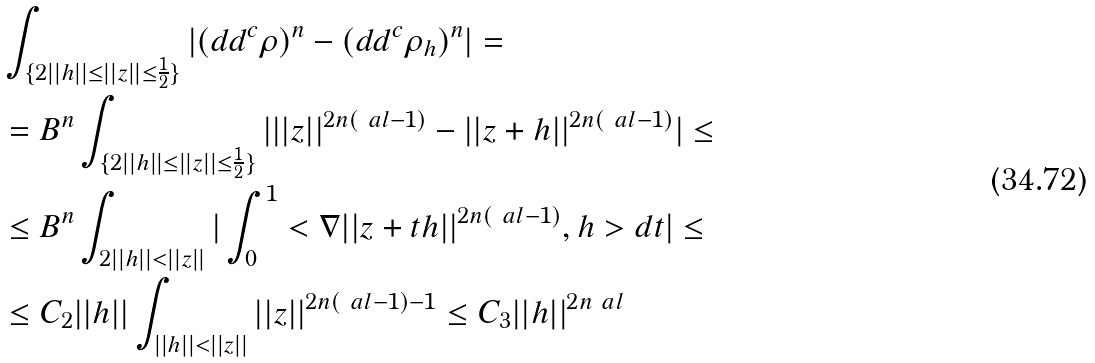<formula> <loc_0><loc_0><loc_500><loc_500>& \int _ { \{ 2 | | h | | \leq | | z | | \leq \frac { 1 } { 2 } \} } | ( d d ^ { c } \rho ) ^ { n } - ( d d ^ { c } \rho _ { h } ) ^ { n } | = \\ & = B ^ { n } \int _ { \{ 2 | | h | | \leq | | z | | \leq \frac { 1 } { 2 } \} } | | | z | | ^ { 2 n ( \ a l - 1 ) } - | | z + h | | ^ { 2 n ( \ a l - 1 ) } | \leq \\ & \leq B ^ { n } \int _ { 2 | | h | | < | | z | | } | \int _ { 0 } ^ { 1 } < \nabla | | z + t h | | ^ { 2 n ( \ a l - 1 ) } , h > d t | \leq \\ & \leq C _ { 2 } | | h | | \int _ { | | h | | < | | z | | } | | z | | ^ { 2 n ( \ a l - 1 ) - 1 } \leq C _ { 3 } | | h | | ^ { 2 n \ a l }</formula> 